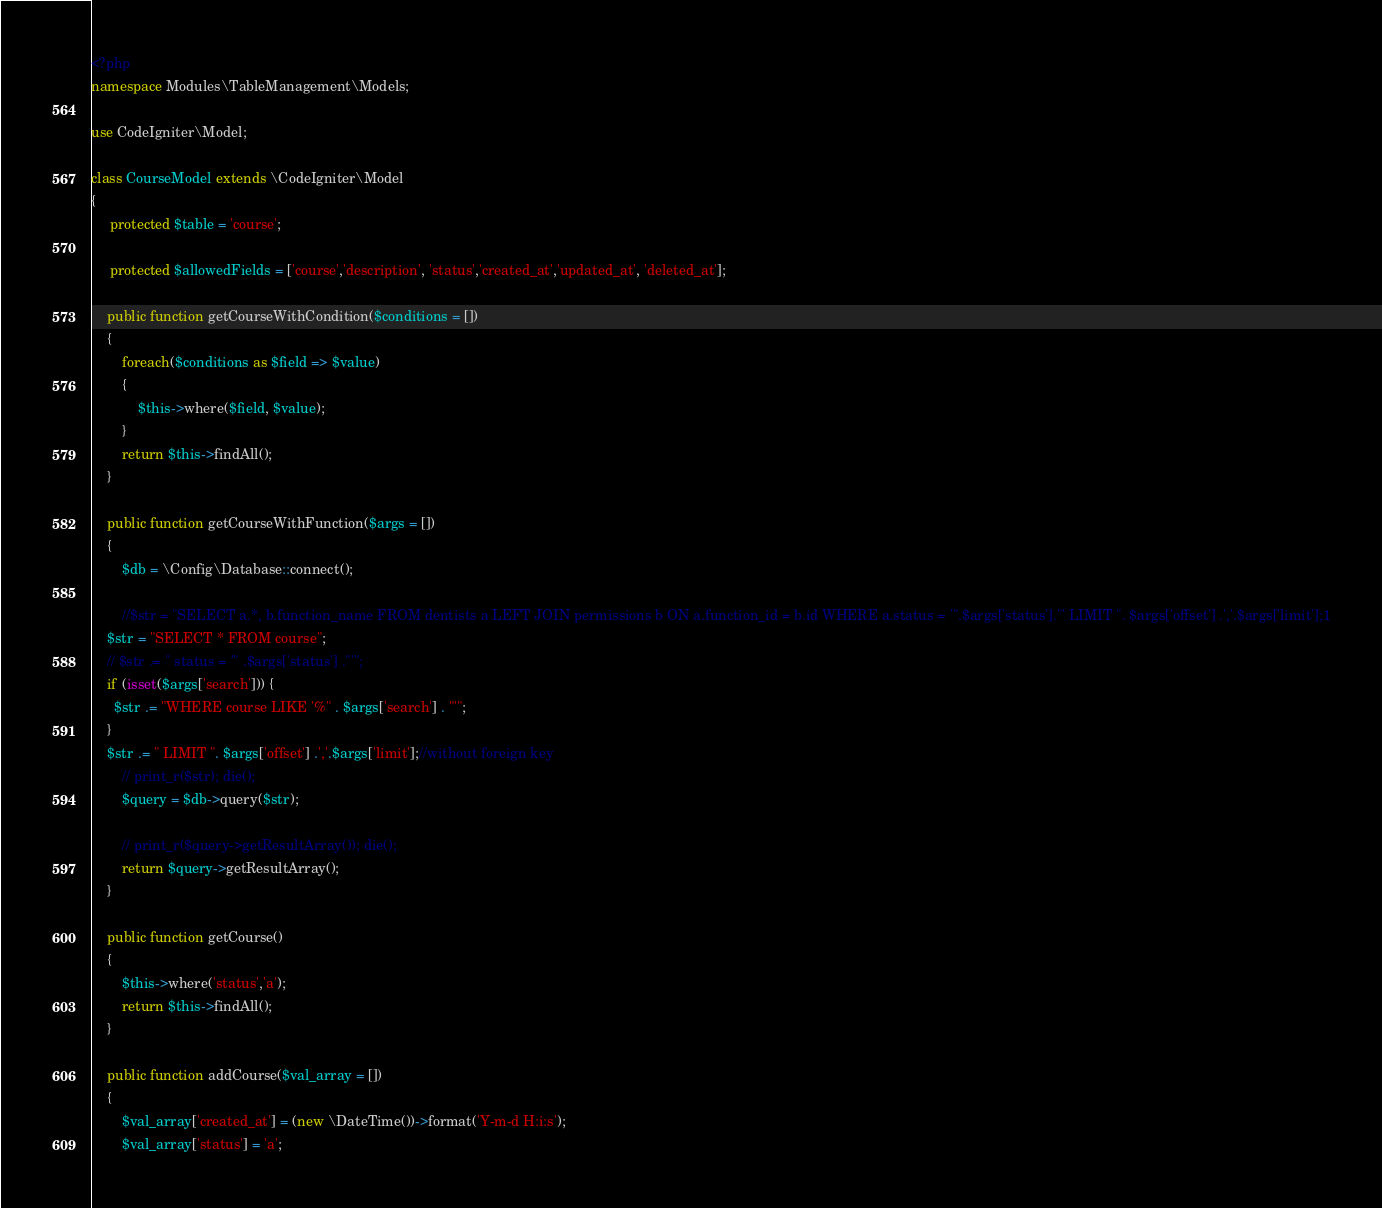<code> <loc_0><loc_0><loc_500><loc_500><_PHP_><?php
namespace Modules\TableManagement\Models;

use CodeIgniter\Model;

class CourseModel extends \CodeIgniter\Model
{
     protected $table = 'course';

     protected $allowedFields = ['course','description', 'status','created_at','updated_at', 'deleted_at'];

    public function getCourseWithCondition($conditions = [])
	{
		foreach($conditions as $field => $value)
		{
			$this->where($field, $value);
		}
	    return $this->findAll();
	}

	public function getCourseWithFunction($args = [])
	{
		$db = \Config\Database::connect();

		//$str = "SELECT a.*, b.function_name FROM dentists a LEFT JOIN permissions b ON a.function_id = b.id WHERE a.status = '".$args['status']."' LIMIT ". $args['offset'] .','.$args['limit'];1
    $str = "SELECT * FROM course";
    // $str .= " status = '" .$args['status'] ."'";
    if (isset($args['search'])) {
      $str .= "WHERE course LIKE '%" . $args['search'] . "'";
    }
    $str .= " LIMIT ". $args['offset'] .','.$args['limit'];//without foreign key
		// print_r($str); die();
		$query = $db->query($str);

		// print_r($query->getResultArray()); die();
	    return $query->getResultArray();
	}

    public function getCourse()
	{
		$this->where('status','a');
	    return $this->findAll();
	}

    public function addCourse($val_array = [])
	{
		$val_array['created_at'] = (new \DateTime())->format('Y-m-d H:i:s');
		$val_array['status'] = 'a';</code> 